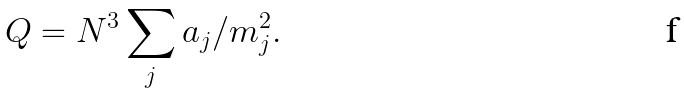Convert formula to latex. <formula><loc_0><loc_0><loc_500><loc_500>Q = N ^ { 3 } \sum _ { j } a _ { j } / m _ { j } ^ { 2 } .</formula> 